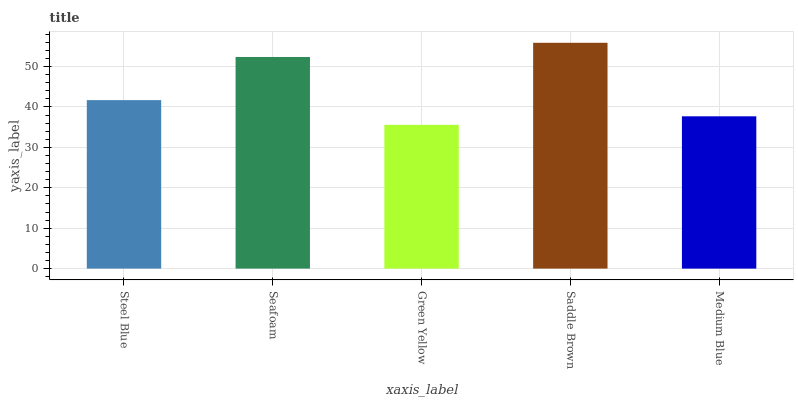Is Green Yellow the minimum?
Answer yes or no. Yes. Is Saddle Brown the maximum?
Answer yes or no. Yes. Is Seafoam the minimum?
Answer yes or no. No. Is Seafoam the maximum?
Answer yes or no. No. Is Seafoam greater than Steel Blue?
Answer yes or no. Yes. Is Steel Blue less than Seafoam?
Answer yes or no. Yes. Is Steel Blue greater than Seafoam?
Answer yes or no. No. Is Seafoam less than Steel Blue?
Answer yes or no. No. Is Steel Blue the high median?
Answer yes or no. Yes. Is Steel Blue the low median?
Answer yes or no. Yes. Is Seafoam the high median?
Answer yes or no. No. Is Seafoam the low median?
Answer yes or no. No. 